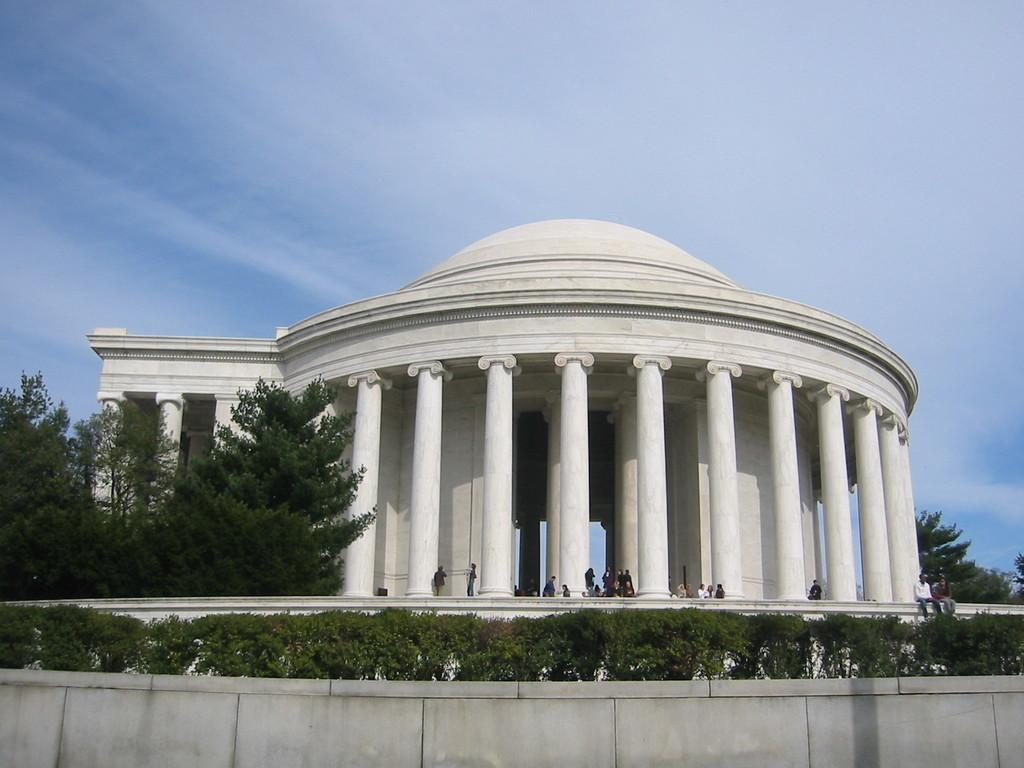What is located in the foreground of the image? In the foreground of the image, there is a fence, plants, trees, and a group of people. What can be seen in the background of the image? In the background of the image, there are pillars, a building, and the sky. Can you describe the time of day when the image was taken? The image was likely taken during the day, as the sky is visible and not dark. What is the result of adding the number of trees and pillars in the image? There is no need to perform addition in this context, as the image does not involve numbers or calculations. Are the people in the image driving any vehicles? There is no mention of vehicles or driving in the image, as it focuses on the fence, plants, trees, group of people, pillars, building, and sky. 